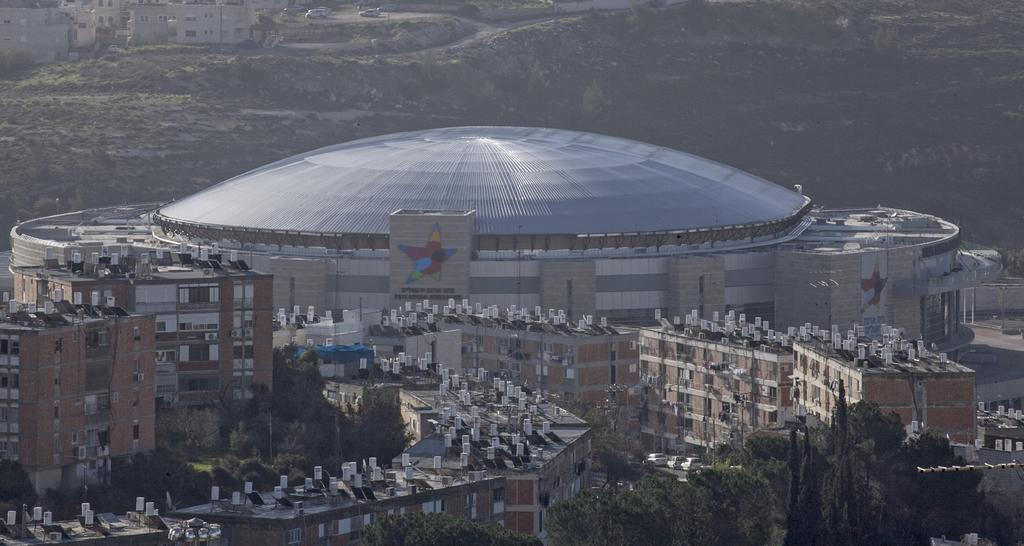What type of structures can be seen in the image? There are buildings in the image. What colors are the buildings? The buildings are in brown and cream colors. What type of vegetation is present in the image? There are trees in the image. What color are the trees? The trees are green. What else can be seen in the background of the image? There are vehicles visible in the background of the image. How many hands are visible holding the trees in the image? There are no hands visible holding the trees in the image; the trees are standing on their own. 